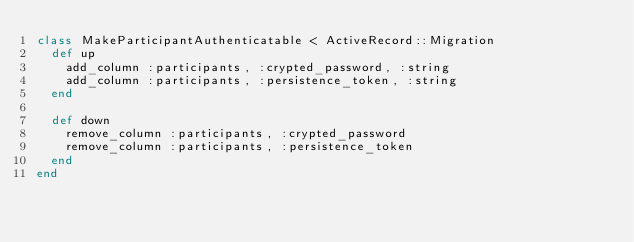Convert code to text. <code><loc_0><loc_0><loc_500><loc_500><_Ruby_>class MakeParticipantAuthenticatable < ActiveRecord::Migration
  def up
    add_column :participants, :crypted_password, :string
    add_column :participants, :persistence_token, :string
  end

  def down
    remove_column :participants, :crypted_password
    remove_column :participants, :persistence_token
  end
end
</code> 